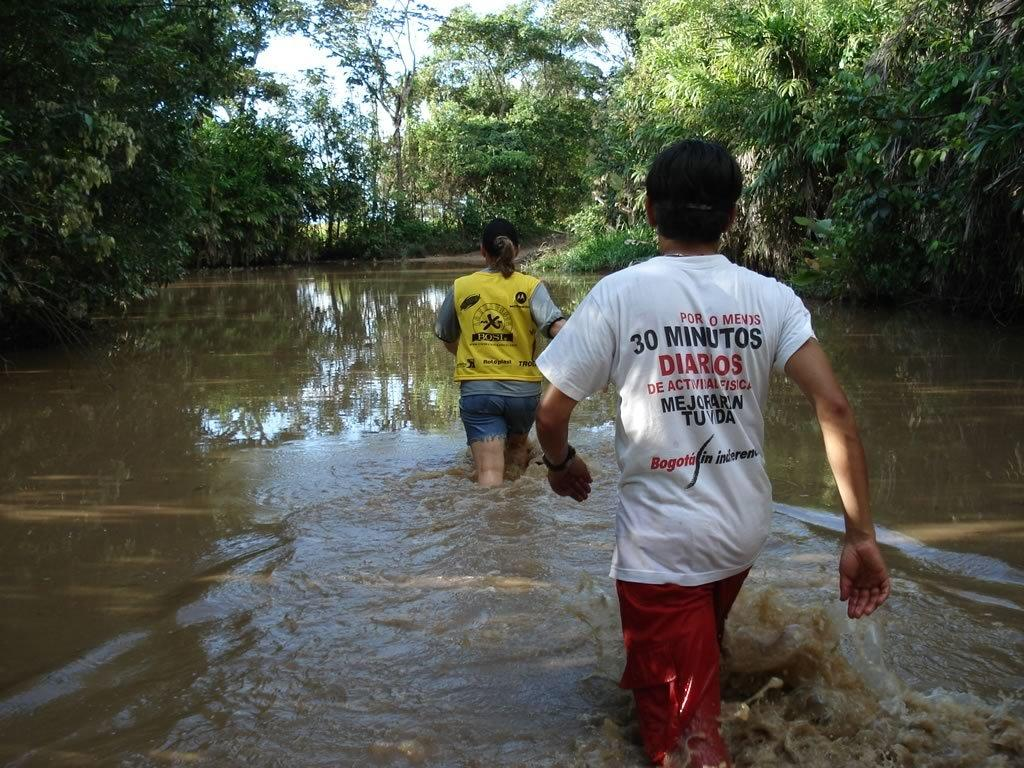Who can be seen in the image? There is a lady and a man in the image. What are the lady and the man doing in the image? Both the lady and the man are walking in the water. What can be seen in the background of the image? There are trees in the background of the image. What type of alley can be seen in the image? There is no alley present in the image; it features a lady and a man walking in the water with trees in the background. 